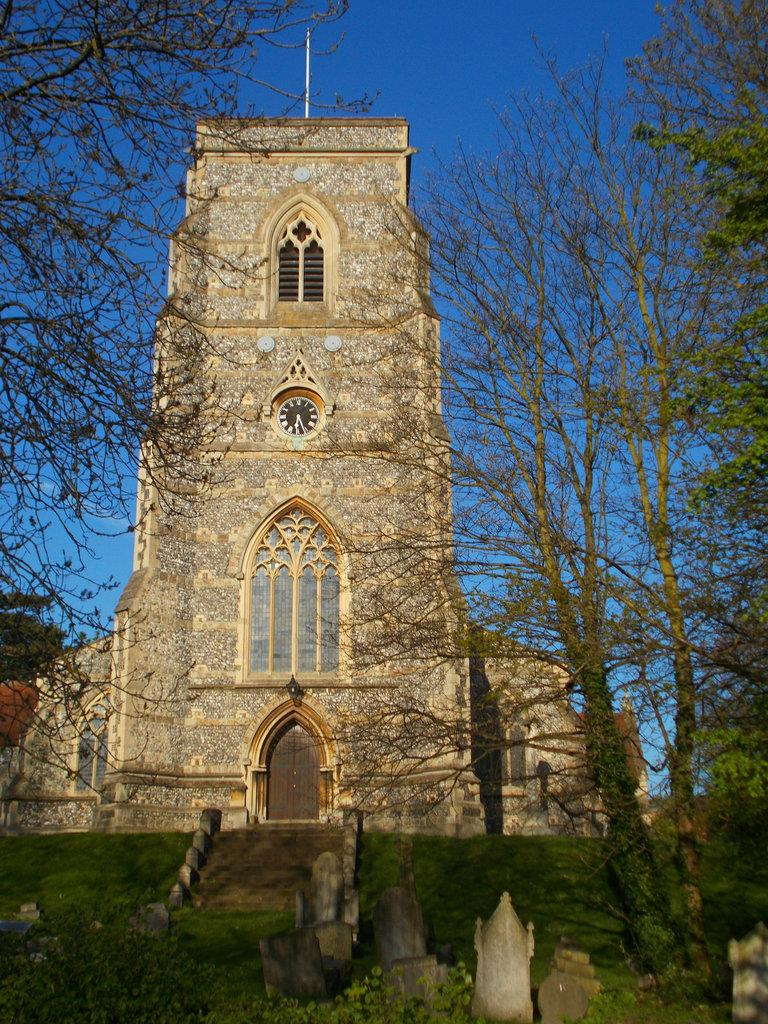What is the main structure in the center of the image? There is a tower in the center of the image. What type of terrain is visible at the bottom of the image? Grass is visible at the bottom of the image. What feature is present at the bottom of the image that allows access to the tower? Stairs are present at the bottom of the image. What can be seen in the background of the image? There are trees and the sky visible in the background of the image. What type of arm is visible on the tower in the image? There are no arms visible on the tower in the image. What instrument is the person playing in the image? There are no people or instruments present in the image. 